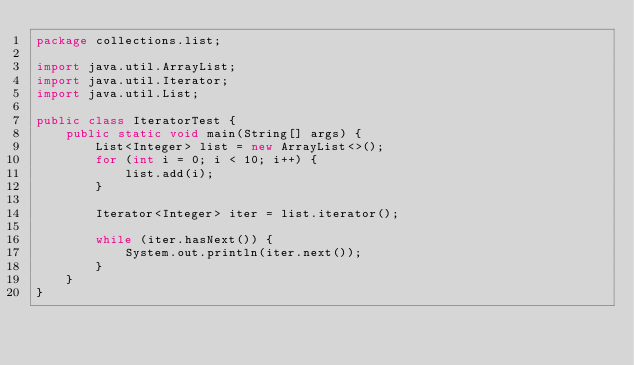<code> <loc_0><loc_0><loc_500><loc_500><_Java_>package collections.list;

import java.util.ArrayList;
import java.util.Iterator;
import java.util.List;

public class IteratorTest {
    public static void main(String[] args) {
        List<Integer> list = new ArrayList<>();
        for (int i = 0; i < 10; i++) {
            list.add(i);
        }

        Iterator<Integer> iter = list.iterator();

        while (iter.hasNext()) {
            System.out.println(iter.next());
        }
    }
}
</code> 